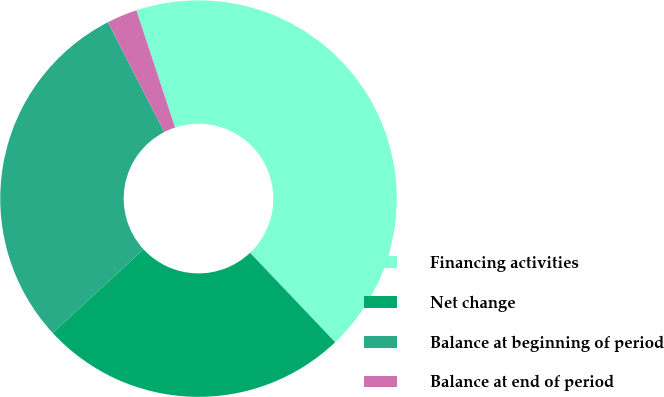Convert chart. <chart><loc_0><loc_0><loc_500><loc_500><pie_chart><fcel>Financing activities<fcel>Net change<fcel>Balance at beginning of period<fcel>Balance at end of period<nl><fcel>42.97%<fcel>25.25%<fcel>29.3%<fcel>2.48%<nl></chart> 